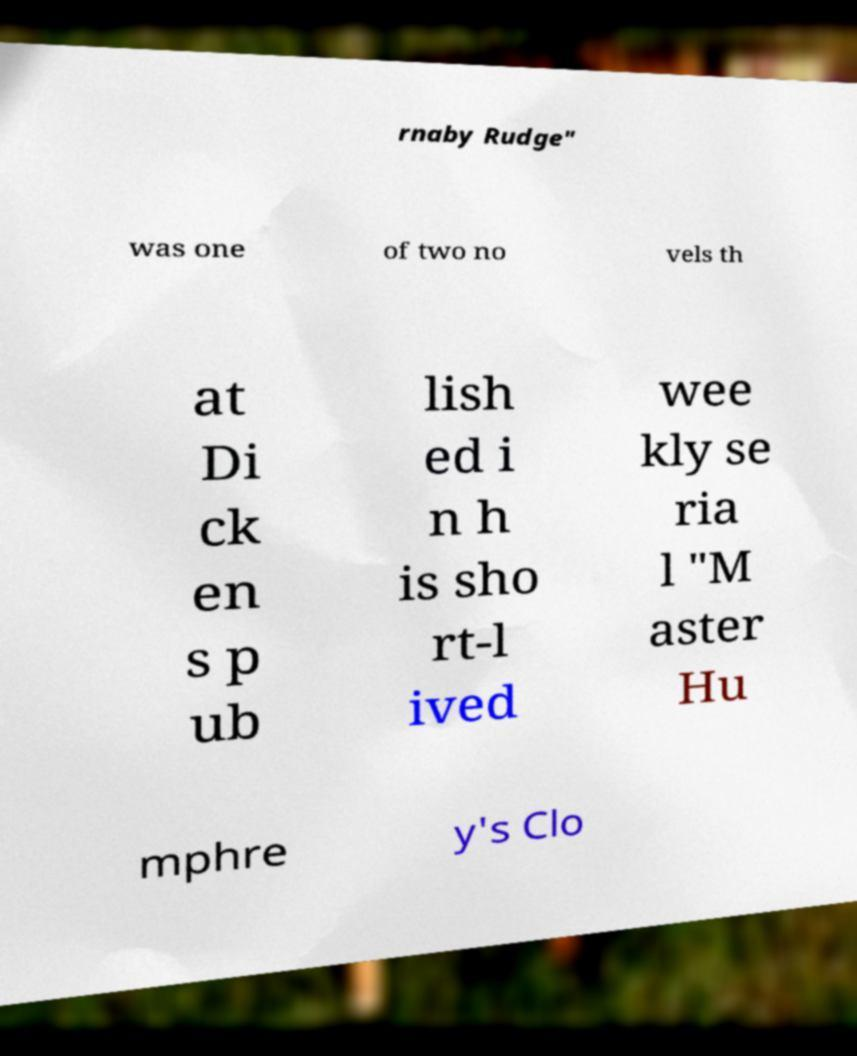Could you assist in decoding the text presented in this image and type it out clearly? rnaby Rudge" was one of two no vels th at Di ck en s p ub lish ed i n h is sho rt-l ived wee kly se ria l "M aster Hu mphre y's Clo 